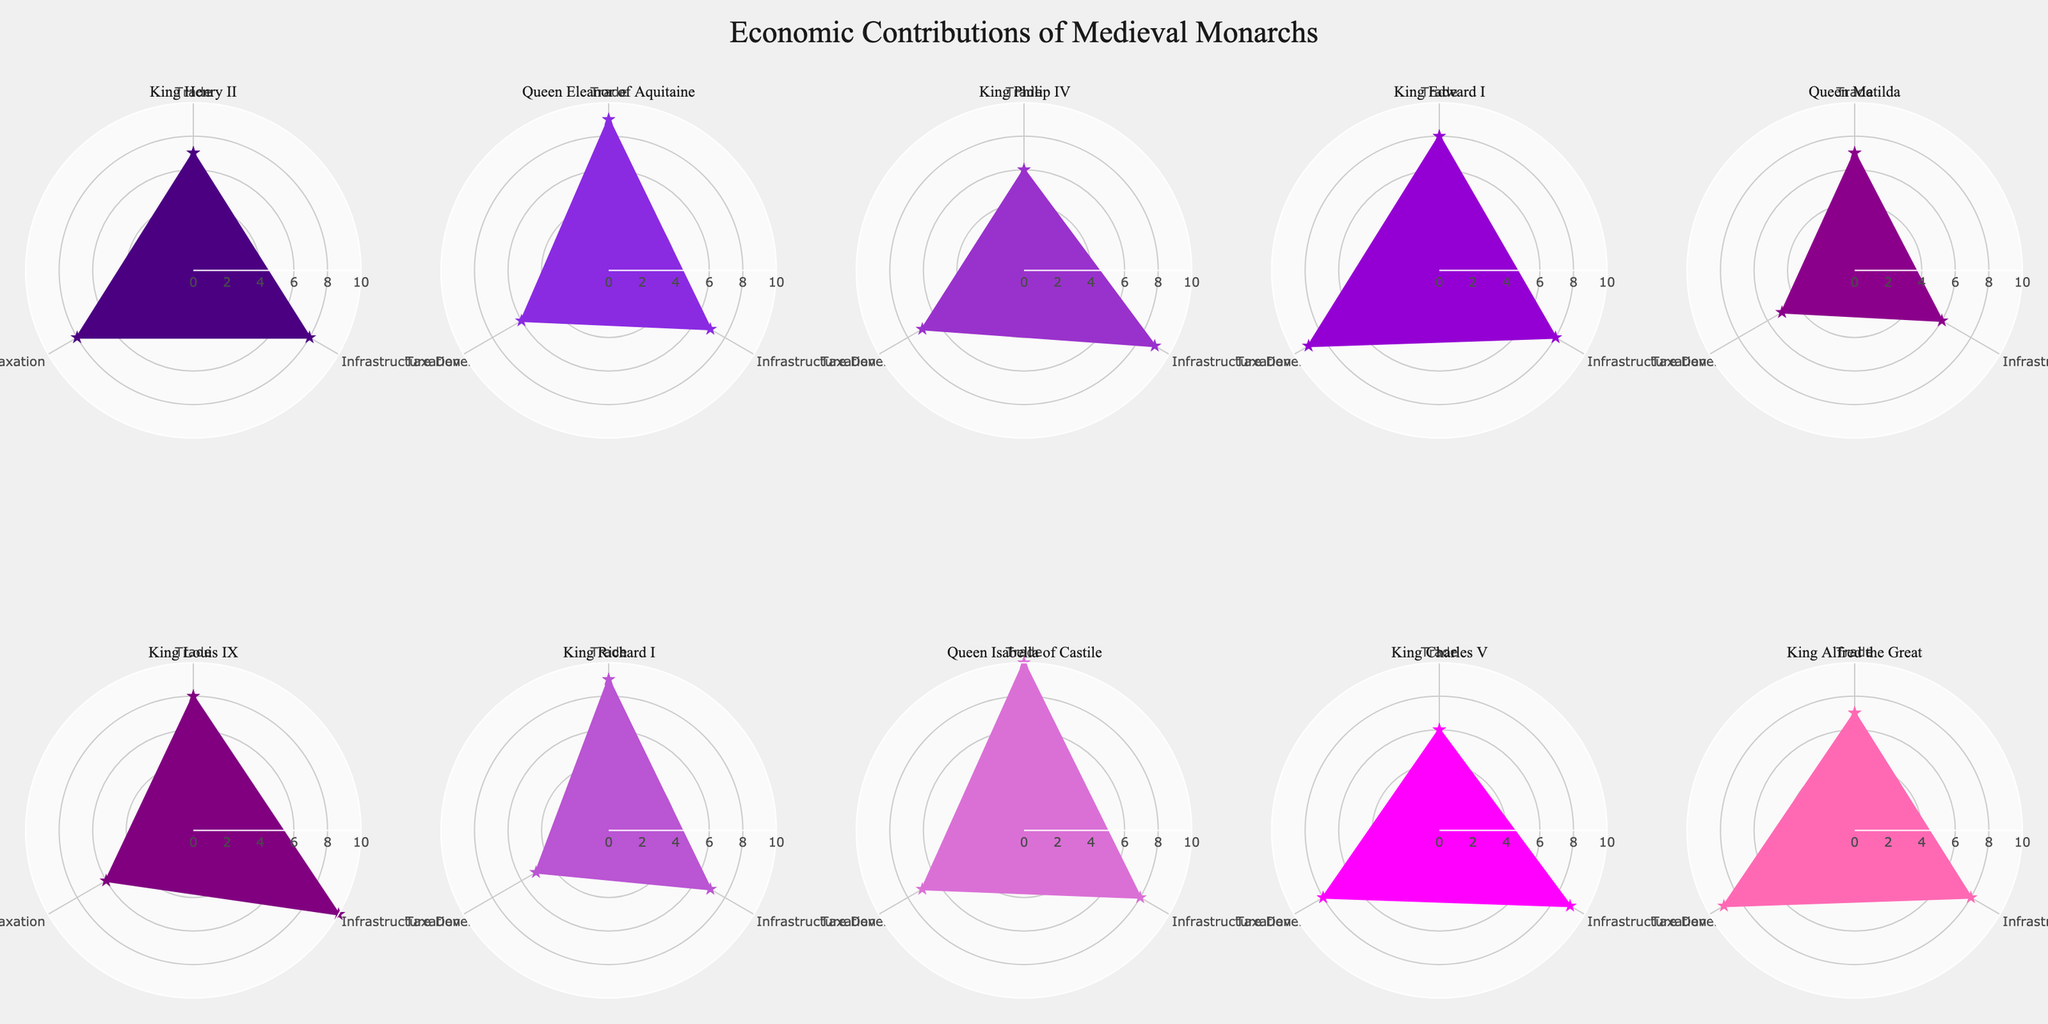What is the title of the chart? The title of the chart is typically displayed prominently at the top of the figure. In this case, it can be found in the layout settings of the plot, which state that the title is "Economic Contributions of Medieval Monarchs".
Answer: Economic Contributions of Medieval Monarchs Which monarch has the highest trade contribution? By looking at the radar charts for each monarch, we can compare the trade contributions. Queen Isabella of Castile is shown with a trade value of 10, which is the highest.
Answer: Queen Isabella of Castile What is the range of values on the radial axis? The radial axis range is set to go from 0 to 10, which is visible as part of the figure's polar axis settings.
Answer: 0 to 10 How many monarchs have an equal value for trade and taxation? To determine the number of monarchs with equal values for trade and taxation, we compare these two categories in their respective radar charts. There are two such monarchs: King Charles V (6, 8) and King Alfred the Great (7, 9).
Answer: Two Which category does King Louis IX contribute the most to? In King Louis IX's radar chart, the highest value is observed in the category of infrastructure development, which is a value of 10.
Answer: Infrastructure Development How many monarchs have a trade contribution of 9? By looking at the radar charts, we identify that there are two monarchs with a trade value of 9, which are Queen Eleanor of Aquitaine and King Richard I.
Answer: Two What is the average value of taxation contributions across all monarchs? To find the average, sum up the taxation values (8, 6, 7, 9, 5, 6, 5, 7, 8, 9) which equals 70, and divide by the number of monarchs (10). The average taxation contribution is 70/10 = 7.
Answer: 7 Which monarch has the most balanced contributions across all three categories? A balanced contribution would mean similar values across trade, infrastructure development, and taxation. King Edward I has contributions of 8, 8, and 9, which shows the most balance across categories.
Answer: King Edward I Between King Philip IV and King Henry II, who contributed more to infrastructure development? From the radar charts, King Philip IV's infrastructure development value is 9, whereas King Henry II's is 8. Thus, King Philip IV contributed more.
Answer: King Philip IV 